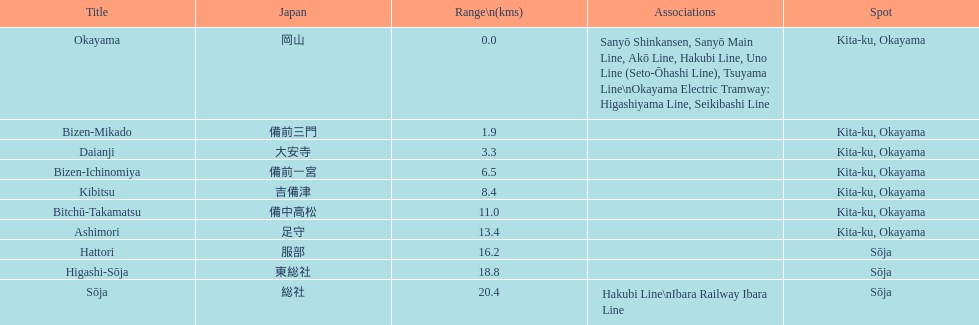How many station are located in kita-ku, okayama? 7. 